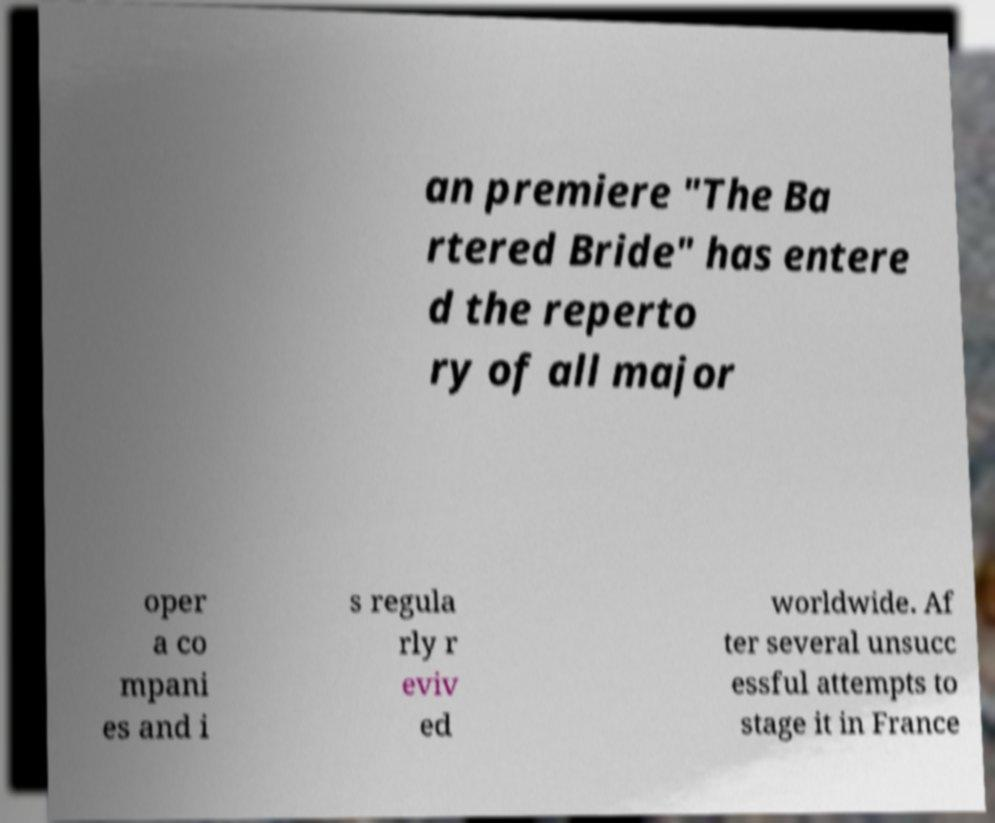Can you accurately transcribe the text from the provided image for me? an premiere "The Ba rtered Bride" has entere d the reperto ry of all major oper a co mpani es and i s regula rly r eviv ed worldwide. Af ter several unsucc essful attempts to stage it in France 